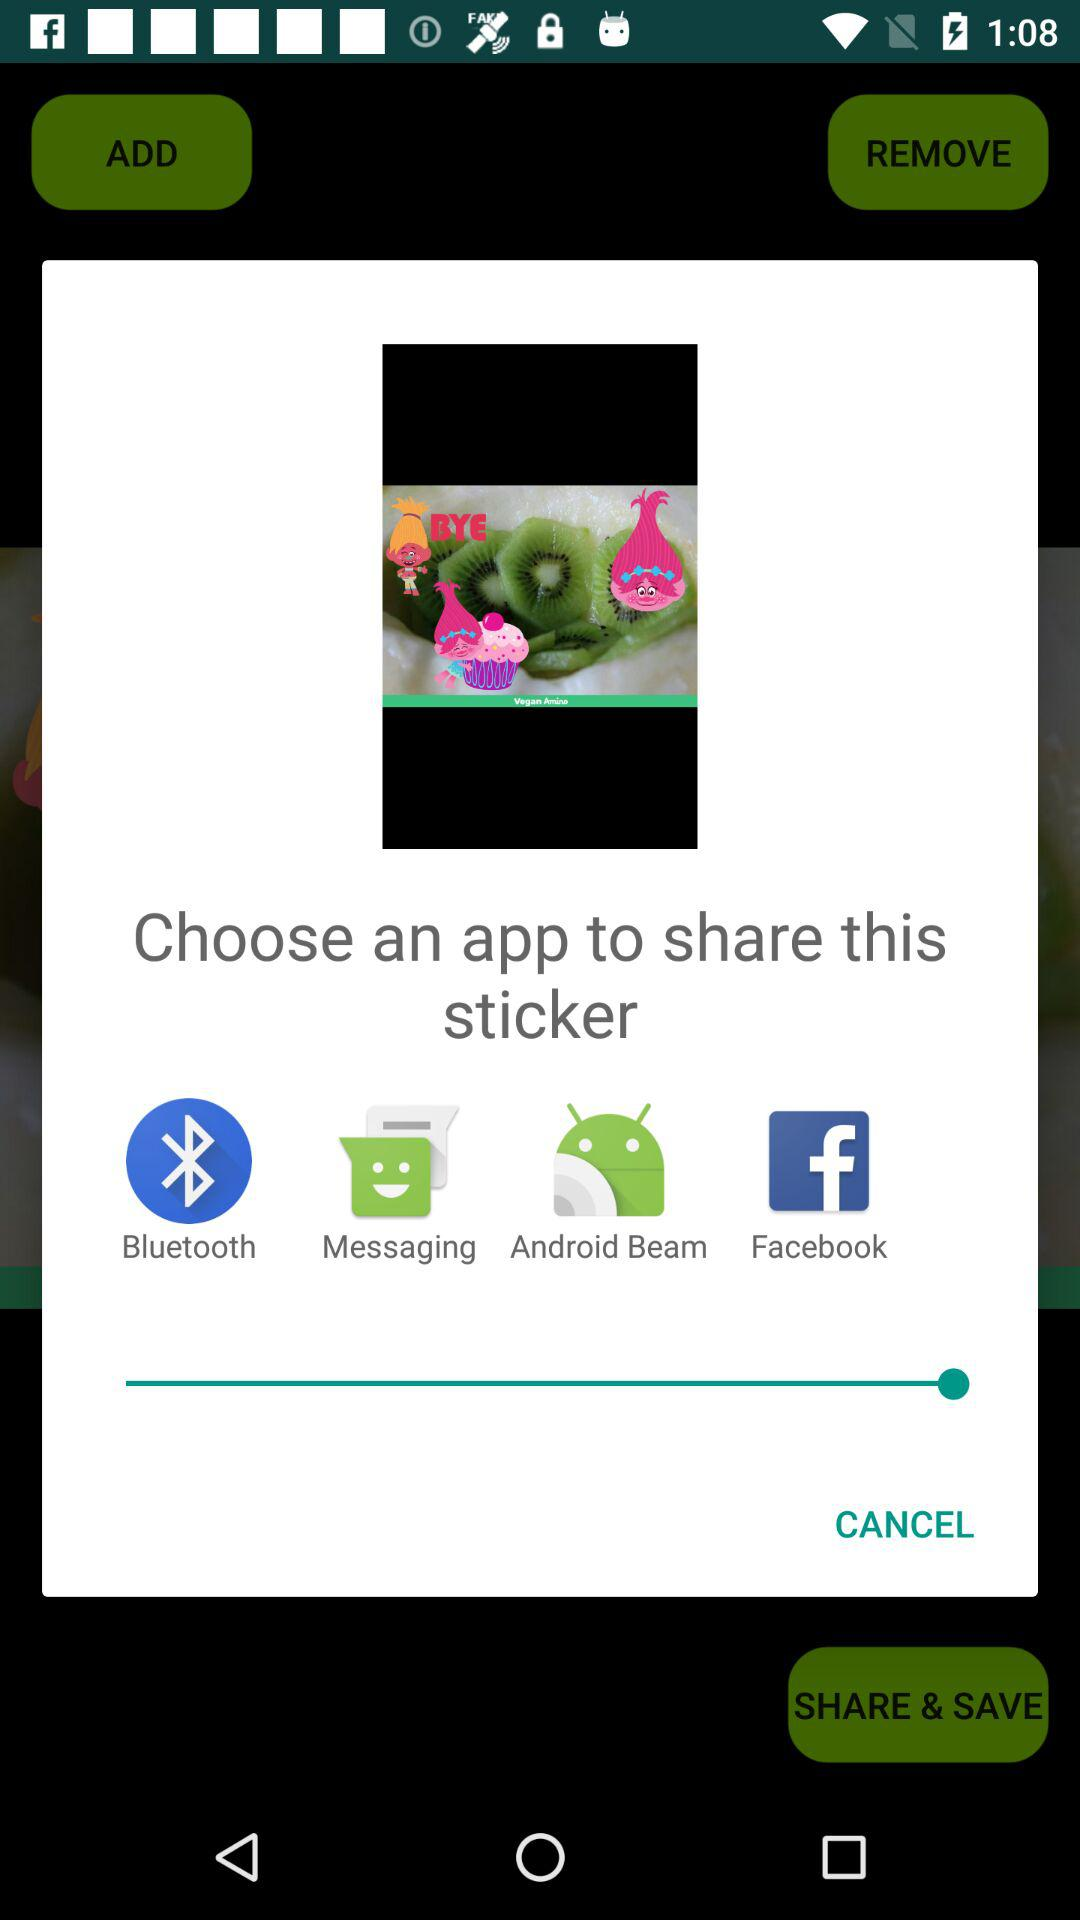How many apps are available to share the sticker?
Answer the question using a single word or phrase. 4 